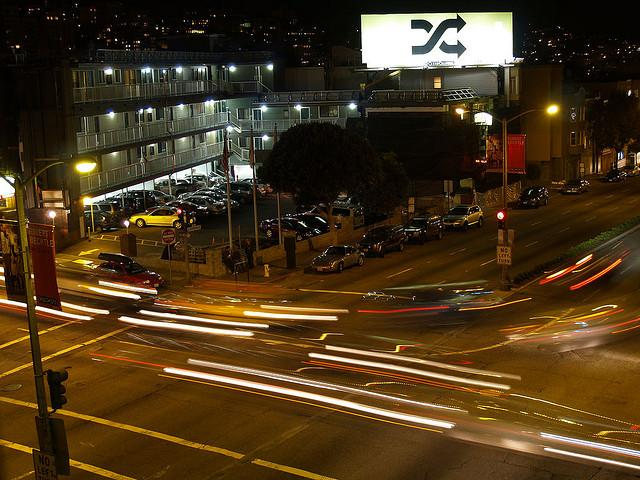What creates the colorful patterns on the ground? lights 